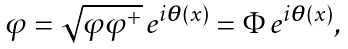<formula> <loc_0><loc_0><loc_500><loc_500>\varphi = \sqrt { \varphi \varphi ^ { + } } \, e ^ { i \boldsymbol \theta ( x ) } = \Phi \, e ^ { i \boldsymbol \theta ( x ) } ,</formula> 